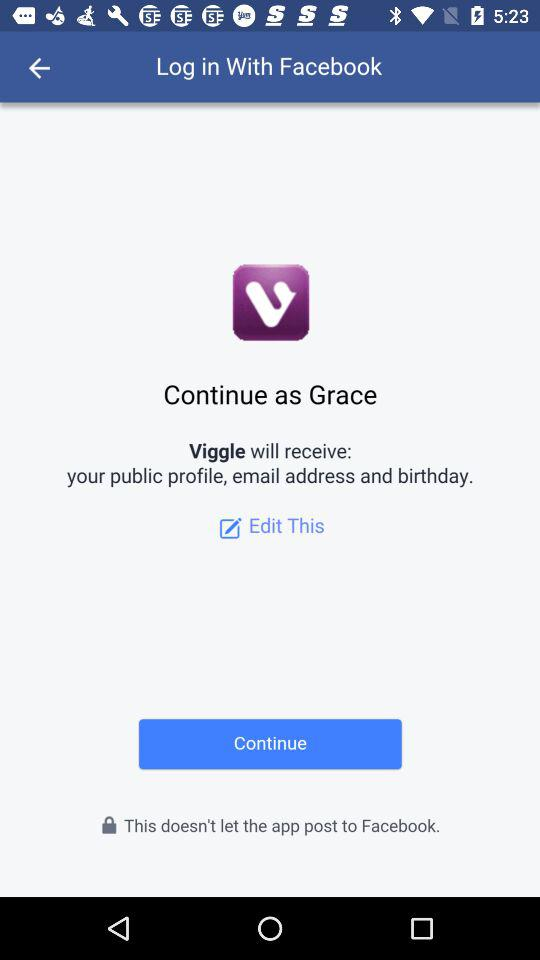What application is asking for permission? The application asking for permission is "Viggle". 